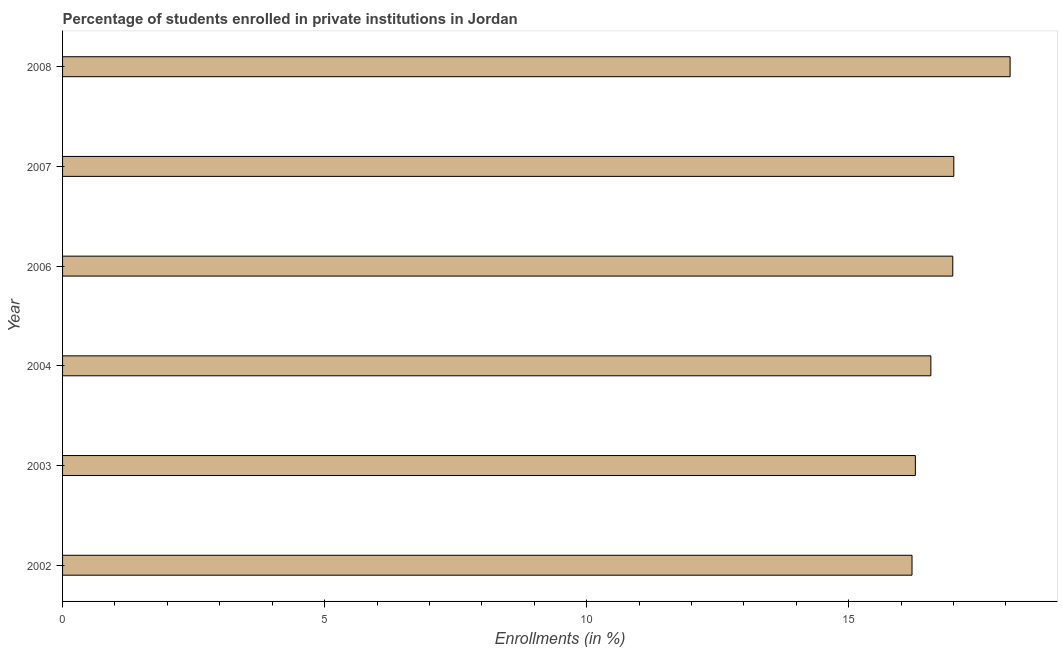Does the graph contain grids?
Give a very brief answer. No. What is the title of the graph?
Make the answer very short. Percentage of students enrolled in private institutions in Jordan. What is the label or title of the X-axis?
Your answer should be compact. Enrollments (in %). What is the label or title of the Y-axis?
Provide a short and direct response. Year. What is the enrollments in private institutions in 2003?
Ensure brevity in your answer.  16.27. Across all years, what is the maximum enrollments in private institutions?
Make the answer very short. 18.08. Across all years, what is the minimum enrollments in private institutions?
Make the answer very short. 16.21. In which year was the enrollments in private institutions maximum?
Your answer should be very brief. 2008. In which year was the enrollments in private institutions minimum?
Your answer should be very brief. 2002. What is the sum of the enrollments in private institutions?
Provide a short and direct response. 101.13. What is the difference between the enrollments in private institutions in 2002 and 2008?
Offer a terse response. -1.87. What is the average enrollments in private institutions per year?
Your answer should be very brief. 16.85. What is the median enrollments in private institutions?
Offer a terse response. 16.78. In how many years, is the enrollments in private institutions greater than 5 %?
Provide a succinct answer. 6. Do a majority of the years between 2007 and 2004 (inclusive) have enrollments in private institutions greater than 5 %?
Offer a terse response. Yes. What is the ratio of the enrollments in private institutions in 2002 to that in 2004?
Your answer should be very brief. 0.98. Is the enrollments in private institutions in 2003 less than that in 2008?
Offer a terse response. Yes. Is the difference between the enrollments in private institutions in 2002 and 2003 greater than the difference between any two years?
Offer a terse response. No. What is the difference between the highest and the second highest enrollments in private institutions?
Your response must be concise. 1.07. What is the difference between the highest and the lowest enrollments in private institutions?
Your response must be concise. 1.87. In how many years, is the enrollments in private institutions greater than the average enrollments in private institutions taken over all years?
Offer a terse response. 3. How many years are there in the graph?
Provide a short and direct response. 6. What is the Enrollments (in %) of 2002?
Your response must be concise. 16.21. What is the Enrollments (in %) in 2003?
Provide a short and direct response. 16.27. What is the Enrollments (in %) of 2004?
Your answer should be very brief. 16.57. What is the Enrollments (in %) in 2006?
Your answer should be very brief. 16.99. What is the Enrollments (in %) in 2007?
Your answer should be compact. 17.01. What is the Enrollments (in %) in 2008?
Keep it short and to the point. 18.08. What is the difference between the Enrollments (in %) in 2002 and 2003?
Ensure brevity in your answer.  -0.06. What is the difference between the Enrollments (in %) in 2002 and 2004?
Offer a terse response. -0.36. What is the difference between the Enrollments (in %) in 2002 and 2006?
Your answer should be compact. -0.78. What is the difference between the Enrollments (in %) in 2002 and 2007?
Offer a very short reply. -0.8. What is the difference between the Enrollments (in %) in 2002 and 2008?
Make the answer very short. -1.87. What is the difference between the Enrollments (in %) in 2003 and 2004?
Offer a terse response. -0.3. What is the difference between the Enrollments (in %) in 2003 and 2006?
Your answer should be compact. -0.71. What is the difference between the Enrollments (in %) in 2003 and 2007?
Give a very brief answer. -0.73. What is the difference between the Enrollments (in %) in 2003 and 2008?
Make the answer very short. -1.81. What is the difference between the Enrollments (in %) in 2004 and 2006?
Provide a short and direct response. -0.42. What is the difference between the Enrollments (in %) in 2004 and 2007?
Ensure brevity in your answer.  -0.44. What is the difference between the Enrollments (in %) in 2004 and 2008?
Ensure brevity in your answer.  -1.51. What is the difference between the Enrollments (in %) in 2006 and 2007?
Your response must be concise. -0.02. What is the difference between the Enrollments (in %) in 2006 and 2008?
Your response must be concise. -1.09. What is the difference between the Enrollments (in %) in 2007 and 2008?
Ensure brevity in your answer.  -1.07. What is the ratio of the Enrollments (in %) in 2002 to that in 2006?
Give a very brief answer. 0.95. What is the ratio of the Enrollments (in %) in 2002 to that in 2007?
Give a very brief answer. 0.95. What is the ratio of the Enrollments (in %) in 2002 to that in 2008?
Give a very brief answer. 0.9. What is the ratio of the Enrollments (in %) in 2003 to that in 2004?
Offer a terse response. 0.98. What is the ratio of the Enrollments (in %) in 2003 to that in 2006?
Keep it short and to the point. 0.96. What is the ratio of the Enrollments (in %) in 2003 to that in 2007?
Offer a terse response. 0.96. What is the ratio of the Enrollments (in %) in 2004 to that in 2007?
Ensure brevity in your answer.  0.97. What is the ratio of the Enrollments (in %) in 2004 to that in 2008?
Your answer should be very brief. 0.92. What is the ratio of the Enrollments (in %) in 2006 to that in 2007?
Provide a succinct answer. 1. What is the ratio of the Enrollments (in %) in 2006 to that in 2008?
Offer a very short reply. 0.94. What is the ratio of the Enrollments (in %) in 2007 to that in 2008?
Provide a succinct answer. 0.94. 